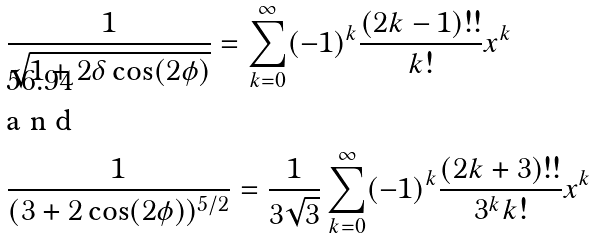Convert formula to latex. <formula><loc_0><loc_0><loc_500><loc_500>& \frac { 1 } { \sqrt { 1 + 2 \delta \cos ( 2 \phi ) } } = \sum _ { k = 0 } ^ { \infty } ( - 1 ) ^ { k } \frac { ( 2 k - 1 ) ! ! } { k ! } x ^ { k } \intertext { a n d } & \frac { 1 } { ( 3 + 2 \cos ( 2 \phi ) ) ^ { 5 / 2 } } = \frac { 1 } { 3 \sqrt { 3 } } \sum _ { k = 0 } ^ { \infty } ( - 1 ) ^ { k } \frac { ( 2 k + 3 ) ! ! } { 3 ^ { k } k ! } x ^ { k }</formula> 